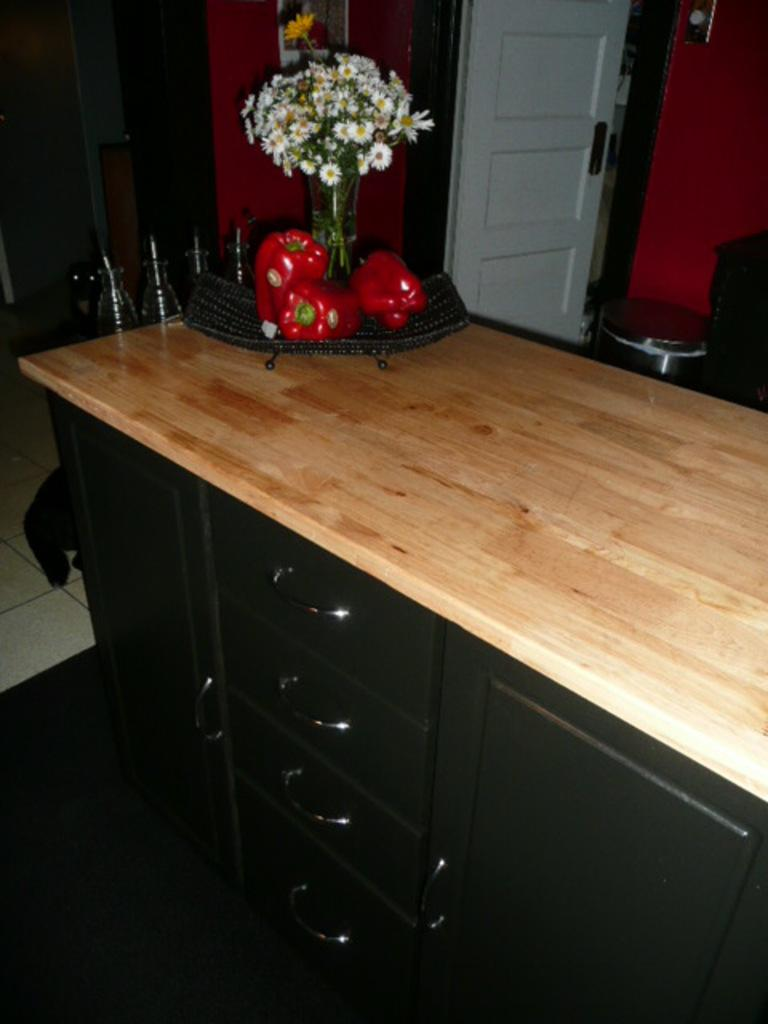What is located in the middle of the image? There is a drawer in the middle of the image. What is inside the drawer? The drawer contains vegetables. What is placed on the drawer also have on it? There is a flower vase on the drawer. What can be seen in the background of the image? There is a door and a wall in the background of the image. How many trucks are parked next to the drawer in the image? There are no trucks present in the image; it features a drawer with vegetables and a flower vase on it, along with a door and a wall in the background. Can you tell me how many chess pieces are on the drawer? There is no chess set present in the image; it features a drawer with vegetables and a flower vase on it, along with a door and a wall in the background. 